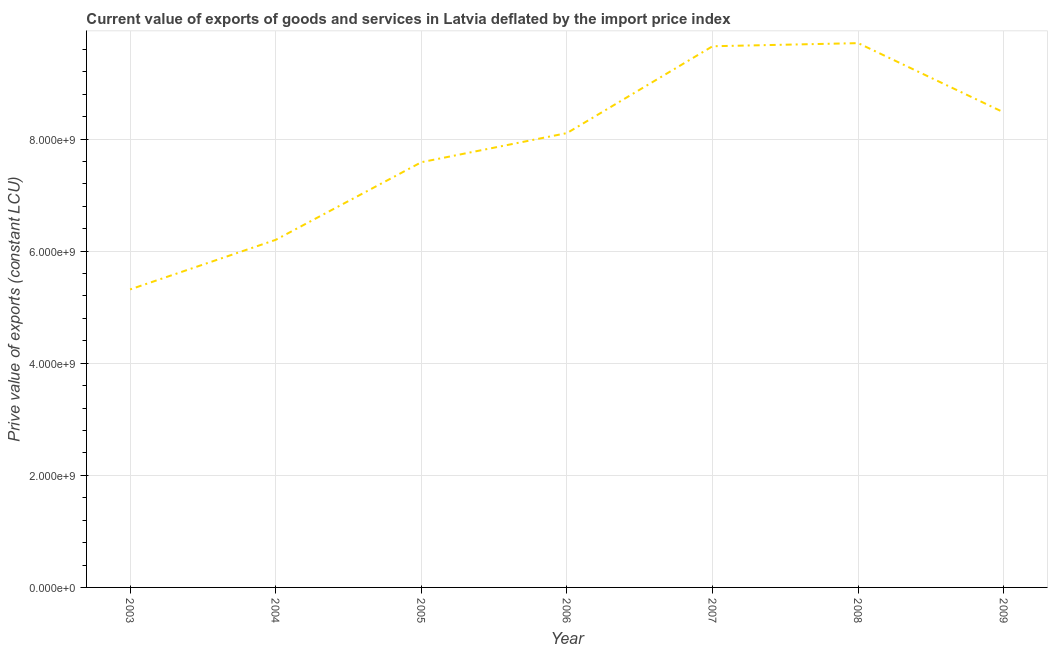What is the price value of exports in 2003?
Offer a very short reply. 5.32e+09. Across all years, what is the maximum price value of exports?
Ensure brevity in your answer.  9.71e+09. Across all years, what is the minimum price value of exports?
Keep it short and to the point. 5.32e+09. In which year was the price value of exports minimum?
Offer a very short reply. 2003. What is the sum of the price value of exports?
Your answer should be very brief. 5.51e+1. What is the difference between the price value of exports in 2005 and 2008?
Ensure brevity in your answer.  -2.12e+09. What is the average price value of exports per year?
Your answer should be very brief. 7.86e+09. What is the median price value of exports?
Give a very brief answer. 8.11e+09. What is the ratio of the price value of exports in 2004 to that in 2009?
Ensure brevity in your answer.  0.73. Is the difference between the price value of exports in 2008 and 2009 greater than the difference between any two years?
Provide a short and direct response. No. What is the difference between the highest and the second highest price value of exports?
Your answer should be compact. 5.55e+07. Is the sum of the price value of exports in 2003 and 2006 greater than the maximum price value of exports across all years?
Provide a succinct answer. Yes. What is the difference between the highest and the lowest price value of exports?
Provide a short and direct response. 4.39e+09. In how many years, is the price value of exports greater than the average price value of exports taken over all years?
Your answer should be compact. 4. Does the graph contain any zero values?
Your answer should be compact. No. Does the graph contain grids?
Provide a succinct answer. Yes. What is the title of the graph?
Offer a very short reply. Current value of exports of goods and services in Latvia deflated by the import price index. What is the label or title of the X-axis?
Keep it short and to the point. Year. What is the label or title of the Y-axis?
Offer a terse response. Prive value of exports (constant LCU). What is the Prive value of exports (constant LCU) in 2003?
Make the answer very short. 5.32e+09. What is the Prive value of exports (constant LCU) of 2004?
Your answer should be compact. 6.20e+09. What is the Prive value of exports (constant LCU) in 2005?
Provide a short and direct response. 7.59e+09. What is the Prive value of exports (constant LCU) in 2006?
Ensure brevity in your answer.  8.11e+09. What is the Prive value of exports (constant LCU) of 2007?
Provide a succinct answer. 9.66e+09. What is the Prive value of exports (constant LCU) of 2008?
Make the answer very short. 9.71e+09. What is the Prive value of exports (constant LCU) of 2009?
Offer a very short reply. 8.48e+09. What is the difference between the Prive value of exports (constant LCU) in 2003 and 2004?
Keep it short and to the point. -8.85e+08. What is the difference between the Prive value of exports (constant LCU) in 2003 and 2005?
Give a very brief answer. -2.27e+09. What is the difference between the Prive value of exports (constant LCU) in 2003 and 2006?
Offer a terse response. -2.79e+09. What is the difference between the Prive value of exports (constant LCU) in 2003 and 2007?
Give a very brief answer. -4.34e+09. What is the difference between the Prive value of exports (constant LCU) in 2003 and 2008?
Provide a short and direct response. -4.39e+09. What is the difference between the Prive value of exports (constant LCU) in 2003 and 2009?
Your answer should be very brief. -3.16e+09. What is the difference between the Prive value of exports (constant LCU) in 2004 and 2005?
Make the answer very short. -1.38e+09. What is the difference between the Prive value of exports (constant LCU) in 2004 and 2006?
Your answer should be compact. -1.90e+09. What is the difference between the Prive value of exports (constant LCU) in 2004 and 2007?
Ensure brevity in your answer.  -3.45e+09. What is the difference between the Prive value of exports (constant LCU) in 2004 and 2008?
Offer a very short reply. -3.51e+09. What is the difference between the Prive value of exports (constant LCU) in 2004 and 2009?
Provide a succinct answer. -2.27e+09. What is the difference between the Prive value of exports (constant LCU) in 2005 and 2006?
Offer a very short reply. -5.20e+08. What is the difference between the Prive value of exports (constant LCU) in 2005 and 2007?
Your response must be concise. -2.07e+09. What is the difference between the Prive value of exports (constant LCU) in 2005 and 2008?
Ensure brevity in your answer.  -2.12e+09. What is the difference between the Prive value of exports (constant LCU) in 2005 and 2009?
Make the answer very short. -8.88e+08. What is the difference between the Prive value of exports (constant LCU) in 2006 and 2007?
Make the answer very short. -1.55e+09. What is the difference between the Prive value of exports (constant LCU) in 2006 and 2008?
Your answer should be compact. -1.60e+09. What is the difference between the Prive value of exports (constant LCU) in 2006 and 2009?
Provide a succinct answer. -3.69e+08. What is the difference between the Prive value of exports (constant LCU) in 2007 and 2008?
Your answer should be very brief. -5.55e+07. What is the difference between the Prive value of exports (constant LCU) in 2007 and 2009?
Give a very brief answer. 1.18e+09. What is the difference between the Prive value of exports (constant LCU) in 2008 and 2009?
Provide a succinct answer. 1.24e+09. What is the ratio of the Prive value of exports (constant LCU) in 2003 to that in 2004?
Provide a succinct answer. 0.86. What is the ratio of the Prive value of exports (constant LCU) in 2003 to that in 2005?
Offer a terse response. 0.7. What is the ratio of the Prive value of exports (constant LCU) in 2003 to that in 2006?
Offer a very short reply. 0.66. What is the ratio of the Prive value of exports (constant LCU) in 2003 to that in 2007?
Your response must be concise. 0.55. What is the ratio of the Prive value of exports (constant LCU) in 2003 to that in 2008?
Ensure brevity in your answer.  0.55. What is the ratio of the Prive value of exports (constant LCU) in 2003 to that in 2009?
Your answer should be compact. 0.63. What is the ratio of the Prive value of exports (constant LCU) in 2004 to that in 2005?
Make the answer very short. 0.82. What is the ratio of the Prive value of exports (constant LCU) in 2004 to that in 2006?
Offer a terse response. 0.77. What is the ratio of the Prive value of exports (constant LCU) in 2004 to that in 2007?
Provide a short and direct response. 0.64. What is the ratio of the Prive value of exports (constant LCU) in 2004 to that in 2008?
Provide a succinct answer. 0.64. What is the ratio of the Prive value of exports (constant LCU) in 2004 to that in 2009?
Keep it short and to the point. 0.73. What is the ratio of the Prive value of exports (constant LCU) in 2005 to that in 2006?
Your response must be concise. 0.94. What is the ratio of the Prive value of exports (constant LCU) in 2005 to that in 2007?
Offer a very short reply. 0.79. What is the ratio of the Prive value of exports (constant LCU) in 2005 to that in 2008?
Provide a short and direct response. 0.78. What is the ratio of the Prive value of exports (constant LCU) in 2005 to that in 2009?
Provide a succinct answer. 0.9. What is the ratio of the Prive value of exports (constant LCU) in 2006 to that in 2007?
Your response must be concise. 0.84. What is the ratio of the Prive value of exports (constant LCU) in 2006 to that in 2008?
Ensure brevity in your answer.  0.83. What is the ratio of the Prive value of exports (constant LCU) in 2006 to that in 2009?
Give a very brief answer. 0.96. What is the ratio of the Prive value of exports (constant LCU) in 2007 to that in 2008?
Your response must be concise. 0.99. What is the ratio of the Prive value of exports (constant LCU) in 2007 to that in 2009?
Make the answer very short. 1.14. What is the ratio of the Prive value of exports (constant LCU) in 2008 to that in 2009?
Your response must be concise. 1.15. 